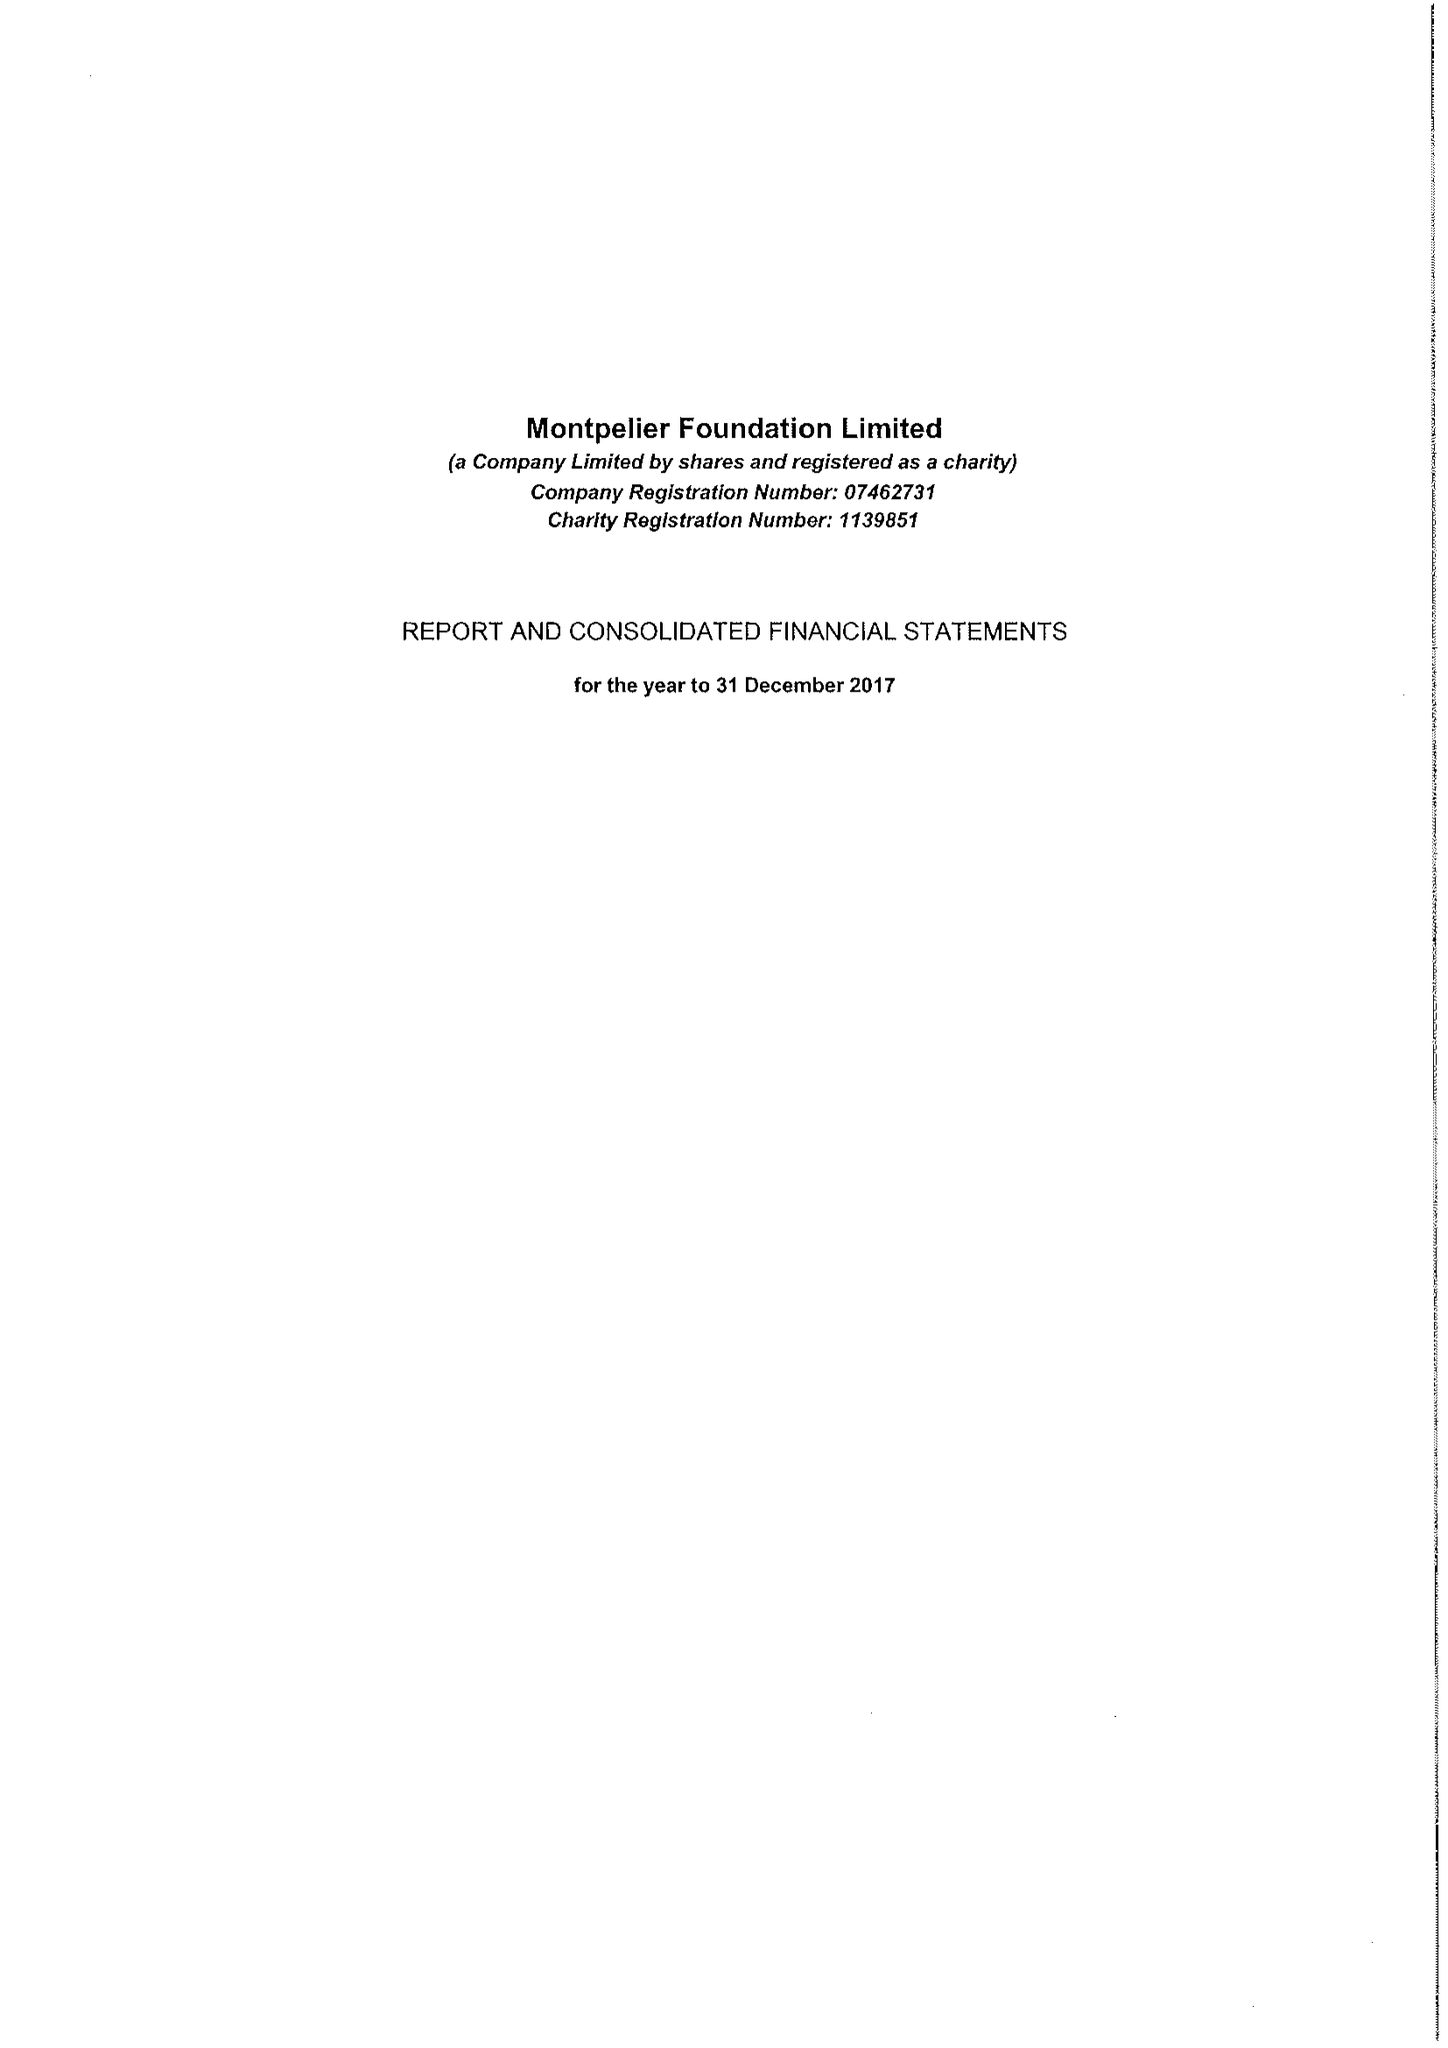What is the value for the address__street_line?
Answer the question using a single word or phrase. 243 KNIGHTSBRIDGE 